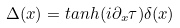Convert formula to latex. <formula><loc_0><loc_0><loc_500><loc_500>\Delta ( x ) = t a n h ( i \partial _ { x } \tau ) \delta ( x )</formula> 